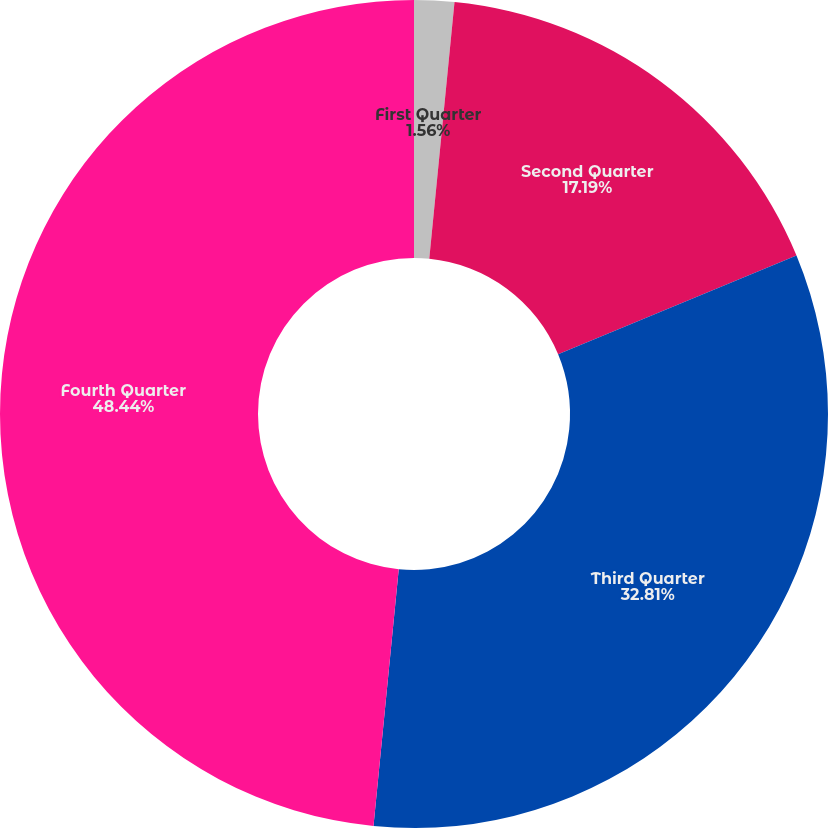Convert chart to OTSL. <chart><loc_0><loc_0><loc_500><loc_500><pie_chart><fcel>First Quarter<fcel>Second Quarter<fcel>Third Quarter<fcel>Fourth Quarter<nl><fcel>1.56%<fcel>17.19%<fcel>32.81%<fcel>48.44%<nl></chart> 